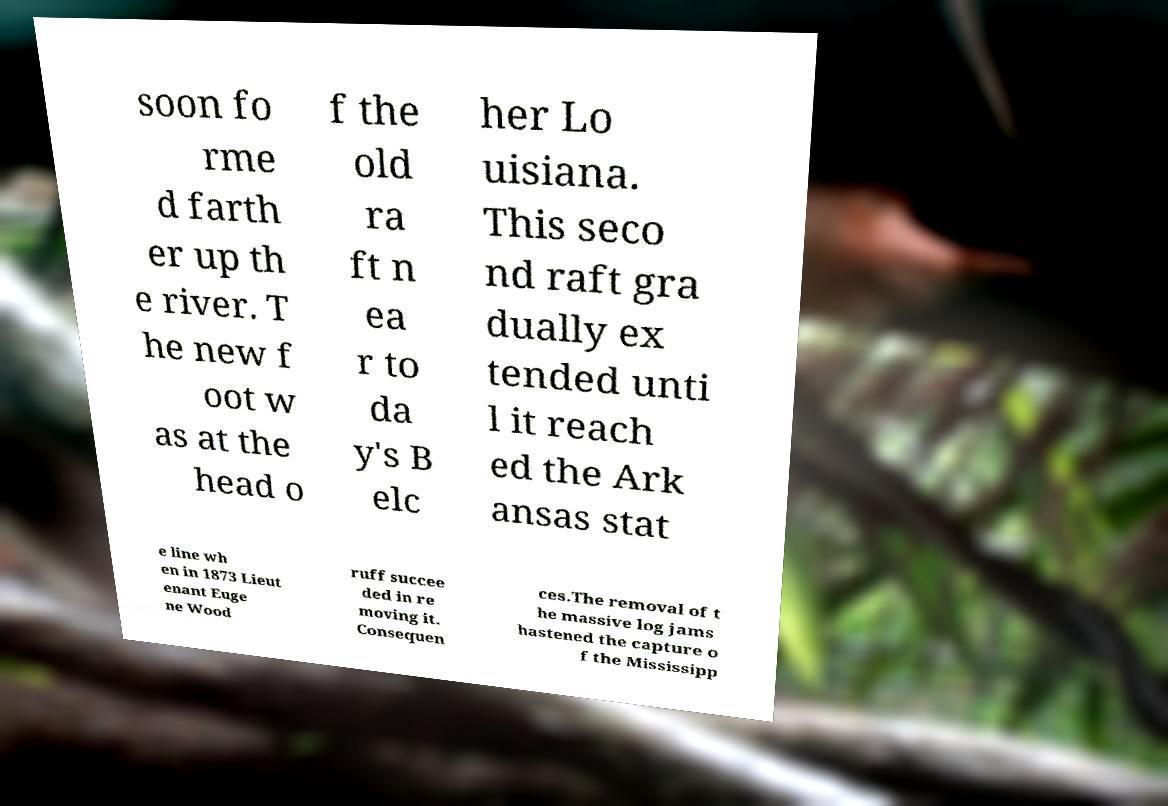I need the written content from this picture converted into text. Can you do that? soon fo rme d farth er up th e river. T he new f oot w as at the head o f the old ra ft n ea r to da y's B elc her Lo uisiana. This seco nd raft gra dually ex tended unti l it reach ed the Ark ansas stat e line wh en in 1873 Lieut enant Euge ne Wood ruff succee ded in re moving it. Consequen ces.The removal of t he massive log jams hastened the capture o f the Mississipp 